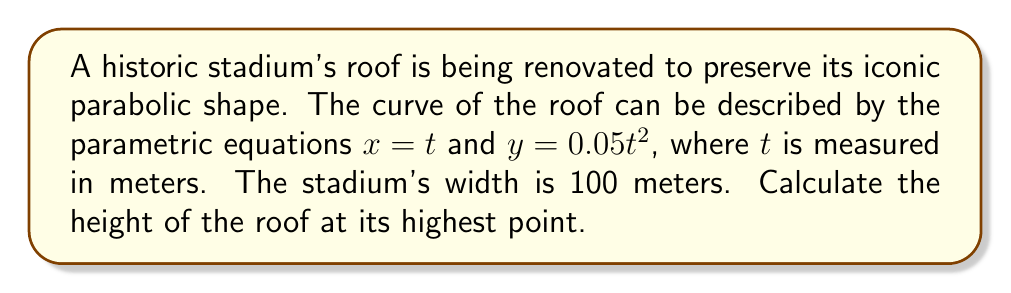What is the answer to this math problem? To solve this problem, we need to follow these steps:

1) The stadium's width is 100 meters, which means the x-coordinate ranges from -50 to 50 meters (assuming the center of the stadium is at x = 0).

2) Given the parametric equations:
   $x = t$
   $y = 0.05t^2$

3) Since $x = t$, we can determine that $t$ ranges from -50 to 50.

4) The highest point of the roof will be at the center of the stadium, where $x = 0$ and $t = 0$.

5) To find the height at any point, we can substitute the value of $t$ into the equation for $y$:

   $y = 0.05t^2$

6) At the highest point, $t = 50$ (or $t = -50$, which gives the same result due to the squared term):

   $y = 0.05(50)^2$
   $y = 0.05(2500)$
   $y = 125$

Therefore, the height of the roof at its highest point is 125 meters.
Answer: The height of the stadium roof at its highest point is 125 meters. 